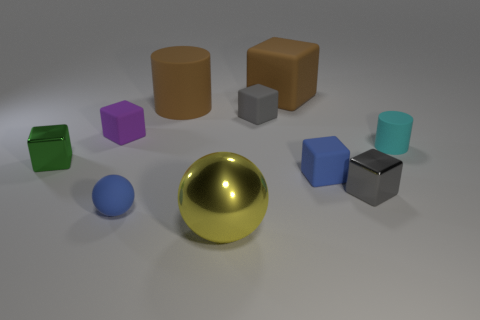What might the arrangement of these objects tell us about the setting or purpose of this image? The deliberate arrangement of these variously colored and shaped objects against a plain background suggests a setup for either a 3D modeling/rendering test or an educational tool to teach about colors, shapes, and shading in a visual arts context. 